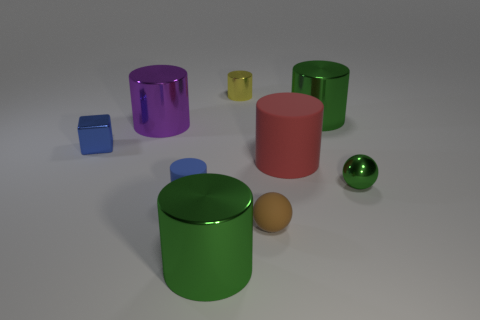There is a big shiny object that is in front of the purple thing; what is its shape?
Make the answer very short. Cylinder. Are there any other things that have the same shape as the tiny yellow thing?
Give a very brief answer. Yes. Is there a large thing?
Ensure brevity in your answer.  Yes. Does the green thing in front of the green sphere have the same size as the matte cylinder that is on the right side of the blue cylinder?
Ensure brevity in your answer.  Yes. There is a big cylinder that is behind the brown matte ball and left of the yellow shiny cylinder; what material is it?
Make the answer very short. Metal. There is a purple metal cylinder; what number of big rubber objects are left of it?
Your response must be concise. 0. Are there any other things that are the same size as the blue metal object?
Offer a terse response. Yes. What is the color of the block that is made of the same material as the purple cylinder?
Offer a very short reply. Blue. Does the tiny green shiny object have the same shape as the tiny brown object?
Offer a terse response. Yes. What number of big metallic objects are both left of the tiny matte sphere and behind the rubber ball?
Keep it short and to the point. 1. 